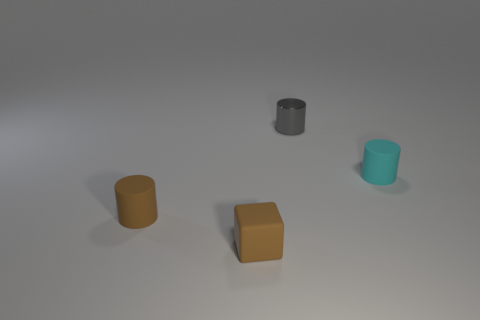Is there any other thing that is made of the same material as the small gray thing?
Ensure brevity in your answer.  No. What material is the tiny gray object?
Offer a terse response. Metal. There is a tiny object that is both on the left side of the tiny gray object and behind the brown matte block; what is its material?
Your answer should be very brief. Rubber. What number of things are either small matte cylinders that are to the left of the small cyan matte thing or big cyan shiny objects?
Offer a very short reply. 1. Is the color of the small block the same as the shiny object?
Ensure brevity in your answer.  No. Are there any green shiny blocks that have the same size as the metal cylinder?
Your answer should be compact. No. What number of rubber things are behind the small cube and in front of the cyan cylinder?
Offer a terse response. 1. There is a gray thing; how many gray objects are on the left side of it?
Provide a succinct answer. 0. Is there another tiny red thing of the same shape as the small metallic object?
Your answer should be very brief. No. There is a tiny cyan object; is its shape the same as the brown matte object that is on the left side of the small brown matte block?
Keep it short and to the point. Yes. 